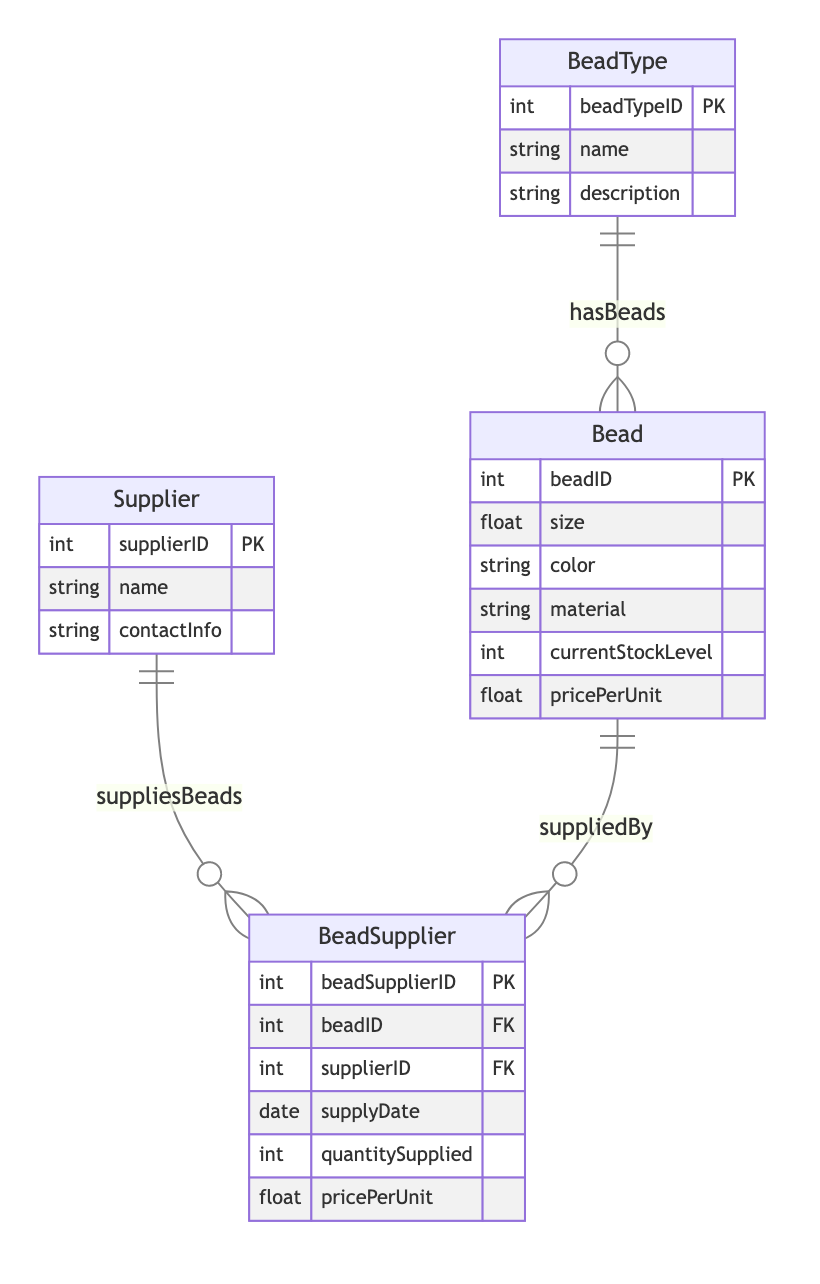What are the attributes of the BeadType entity? The BeadType entity has three attributes as shown in the diagram: beadTypeID, name, and description.
Answer: beadTypeID, name, description How many entities are in this diagram? The diagram lists four entities: BeadType, Supplier, Bead, and BeadSupplier, which can be counted directly from the diagram.
Answer: four What relationship connects BeadType and Bead? The relationship connecting BeadType and Bead is labeled "hasBeads", indicating that each BeadType can have multiple associated Beads.
Answer: hasBeads What is the primary key of the BeadSupplier entity? The primary key for the BeadSupplier entity is beadSupplierID, which is designated as the unique identifier for this entity in the diagram.
Answer: beadSupplierID How many suppliers can supply a bead? According to the diagram, multiple BeadSuppliers can supply a single Bead, indicating that one bead can be associated with many suppliers.
Answer: many What additional attribute does the BeadSupplier include related to pricing? The BeadSupplier entity includes an attribute named pricePerUnit, which indicates the price for each unit supplied by a supplier for each bead.
Answer: pricePerUnit Which entity has a one-to-many relationship with the Supplier entity? The BeadSupplier entity has a one-to-many relationship with the Supplier entity, as shown by the arrow pointing from Supplier to BeadSupplier.
Answer: BeadSupplier How does the Bead and BeadSupplier entities interact? Bead and BeadSupplier have a one-to-many relationship, indicated by the label "suppliedBy", meaning a single bead can have multiple supply entries.
Answer: suppliedBy What type of relationship exists between Supplier and Bead? There is no direct relationship between Supplier and Bead other than through the BeadSupplier entity; hence, there is no direct label.
Answer: none 